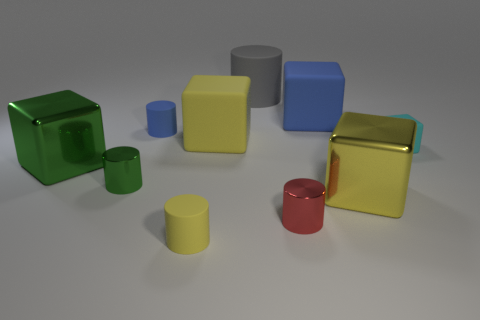Are there any gray objects made of the same material as the blue cube?
Offer a very short reply. Yes. Do the blue object that is right of the gray cylinder and the tiny red object have the same size?
Your answer should be compact. No. There is a yellow cube behind the large shiny block that is left of the big blue matte object; is there a cyan rubber cube behind it?
Make the answer very short. No. How many matte objects are either tiny red things or small green cubes?
Offer a very short reply. 0. How many other things are the same shape as the cyan object?
Provide a short and direct response. 4. Are there more small blue rubber things than tiny metal cylinders?
Give a very brief answer. No. There is a shiny block to the right of the blue rubber object on the left side of the rubber cylinder in front of the tiny block; what size is it?
Ensure brevity in your answer.  Large. What size is the cyan thing behind the green shiny cylinder?
Offer a very short reply. Small. How many things are either yellow rubber cylinders or small metallic objects to the right of the big gray matte object?
Your response must be concise. 2. How many other things are the same size as the green metal block?
Offer a terse response. 4. 